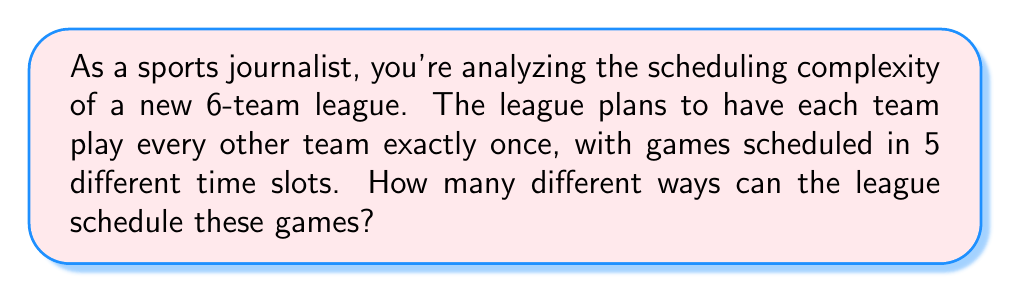Give your solution to this math problem. Let's approach this step-by-step:

1) First, we need to determine the total number of games. With 6 teams, where each team plays every other team once, we can calculate this using the combination formula:

   $${6 \choose 2} = \frac{6!}{2!(6-2)!} = \frac{6 \cdot 5}{2} = 15$$

   So there are 15 total games to be scheduled.

2) Now, we need to distribute these 15 games across 5 time slots. This is equivalent to partitioning 15 objects into 5 non-empty subsets, which is a classic stars and bars problem.

3) The formula for this is:

   $$\binom{n-1}{k-1}$$

   where $n$ is the number of objects (games) and $k$ is the number of subsets (time slots).

4) In this case, $n = 15$ and $k = 5$, so we have:

   $$\binom{15-1}{5-1} = \binom{14}{4}$$

5) We can calculate this:

   $$\binom{14}{4} = \frac{14!}{4!(14-4)!} = \frac{14!}{4!10!} = 1001$$

6) Therefore, there are 1001 ways to distribute the games across the time slots.

7) However, within each time slot, the order of the games doesn't matter. What matters is which teams are playing each other.

Thus, 1001 represents the number of different possible league schedules.
Answer: 1001 